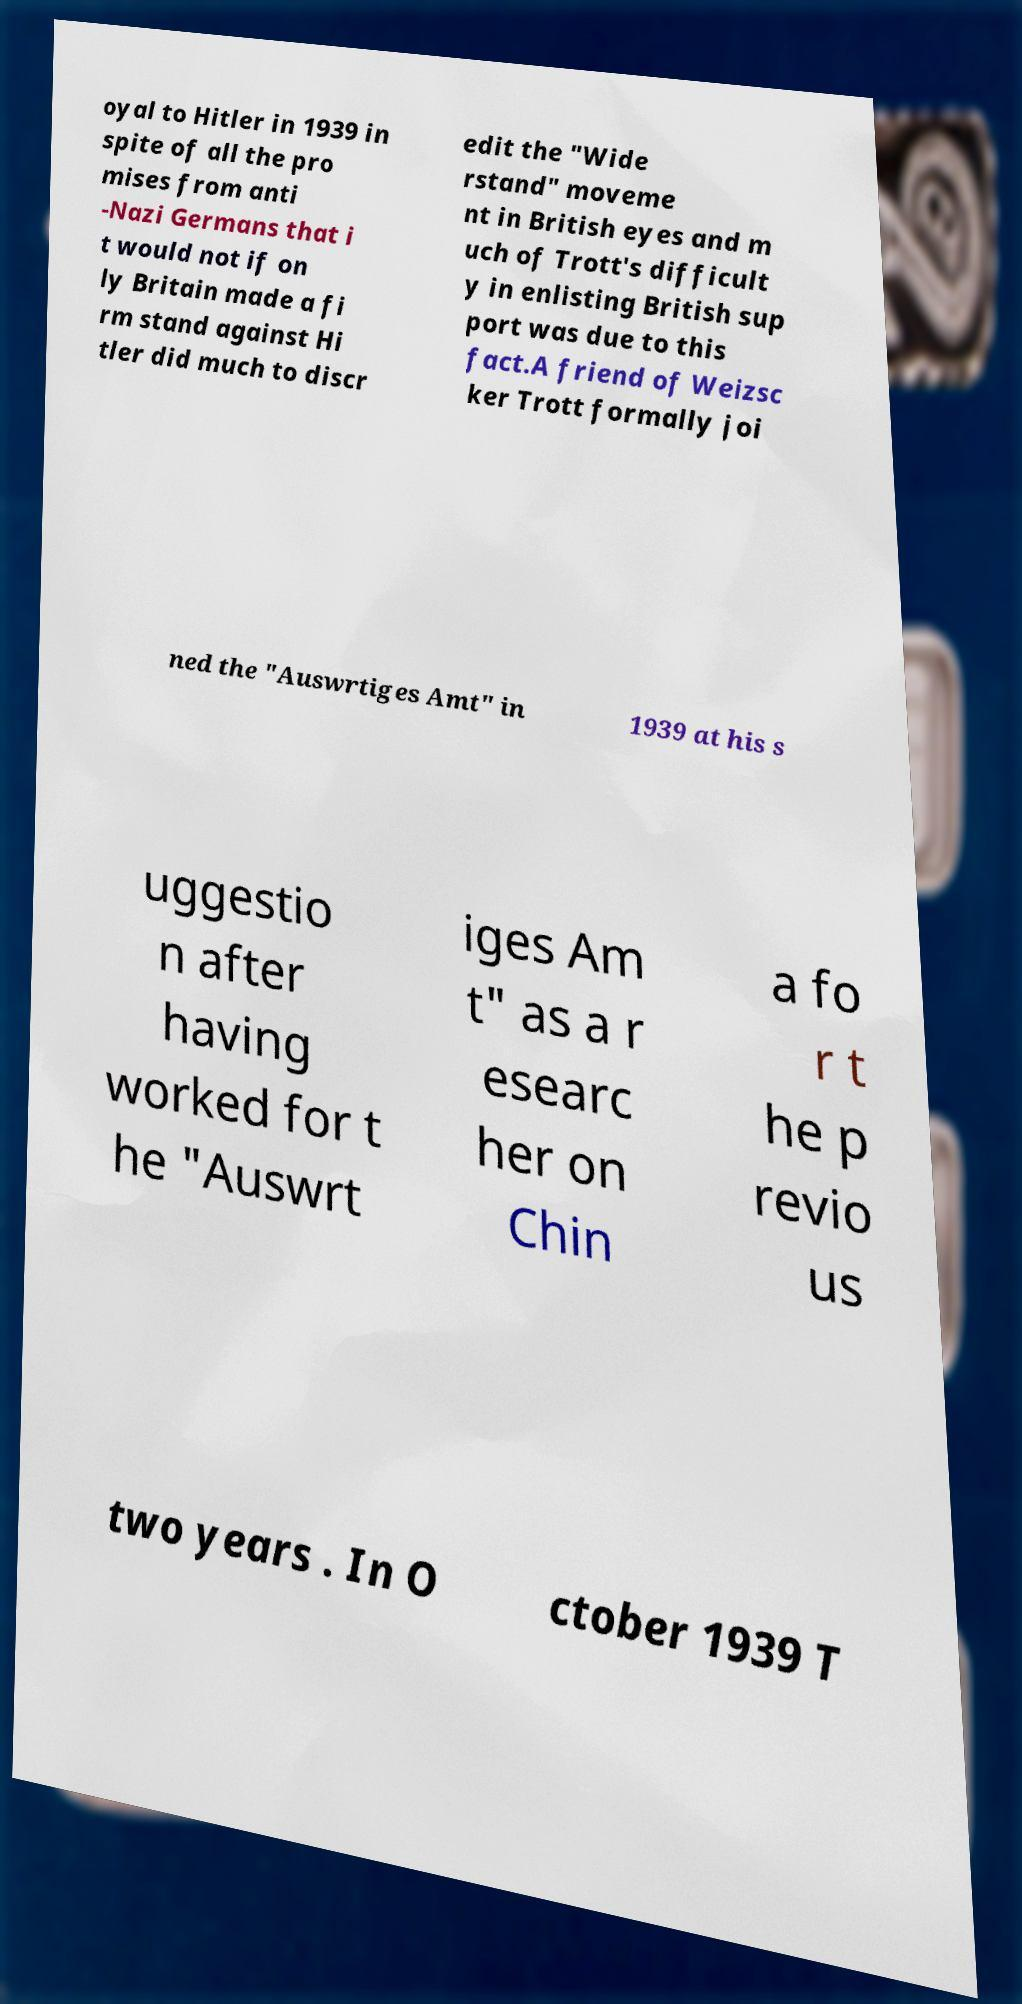What messages or text are displayed in this image? I need them in a readable, typed format. oyal to Hitler in 1939 in spite of all the pro mises from anti -Nazi Germans that i t would not if on ly Britain made a fi rm stand against Hi tler did much to discr edit the "Wide rstand" moveme nt in British eyes and m uch of Trott's difficult y in enlisting British sup port was due to this fact.A friend of Weizsc ker Trott formally joi ned the "Auswrtiges Amt" in 1939 at his s uggestio n after having worked for t he "Auswrt iges Am t" as a r esearc her on Chin a fo r t he p revio us two years . In O ctober 1939 T 